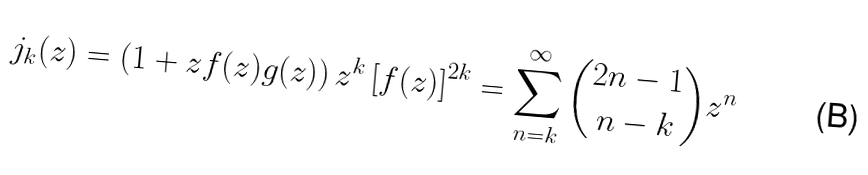<formula> <loc_0><loc_0><loc_500><loc_500>j _ { k } ( z ) = \left ( 1 + z f ( z ) g ( z ) \right ) z ^ { k } \left [ f ( z ) \right ] ^ { 2 k } = \sum _ { n = k } ^ { \infty } { 2 n - 1 \choose n - k } z ^ { n }</formula> 